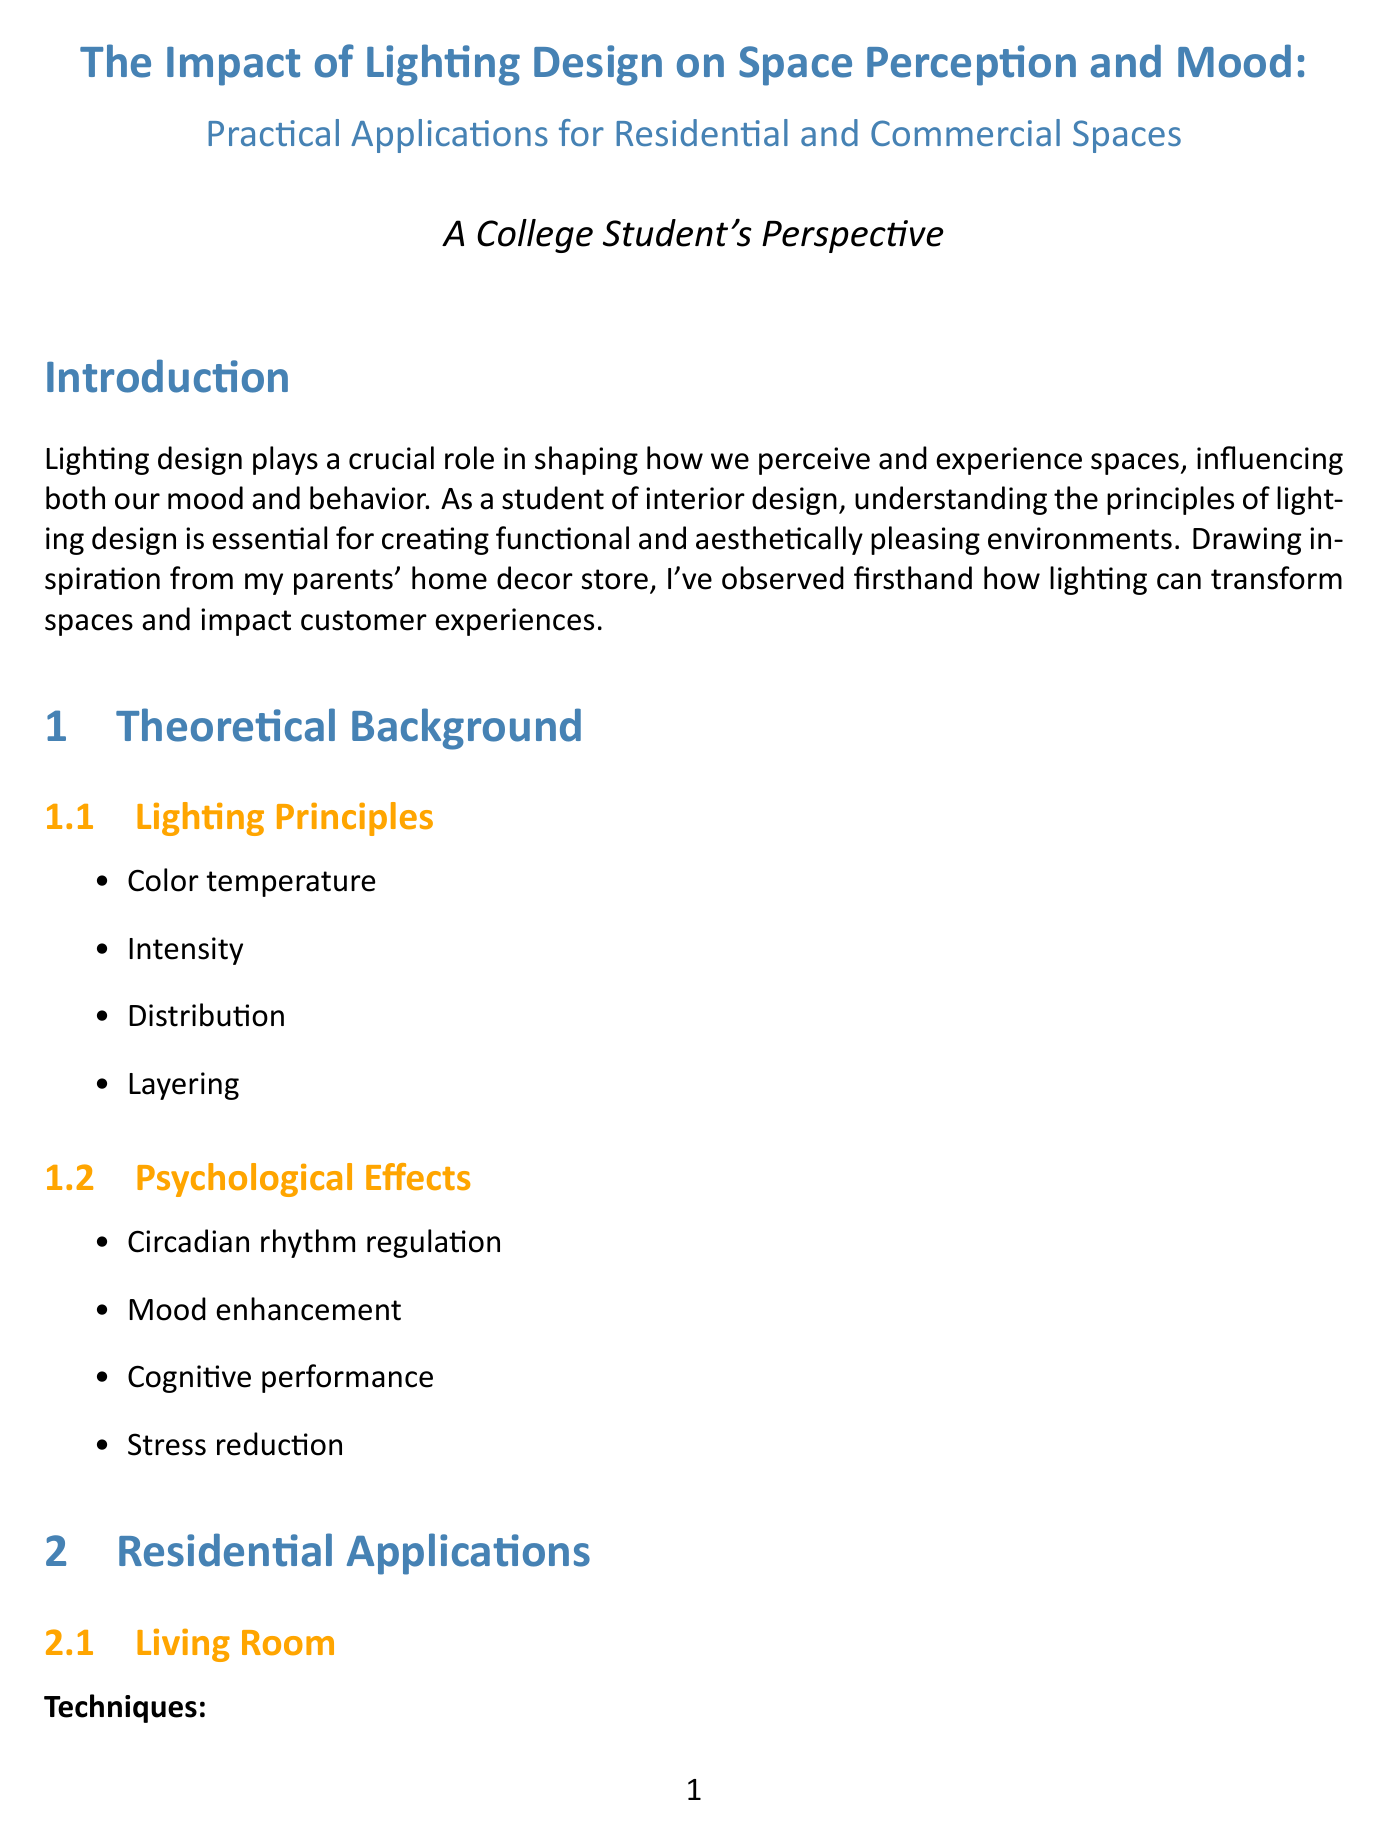what is the report title? The report title is provided in the document's header, outlining the subject matter.
Answer: The Impact of Lighting Design on Space Perception and Mood: Practical Applications for Residential and Commercial Spaces which case study is referenced for bedroom lighting techniques? The case study highlighted for bedroom lighting techniques exemplifies practical application within hospitality spaces.
Answer: Marriott Hotels' StayWell Rooms what is one technique used for kitchen lighting? The document lists specific lighting techniques for various spaces, including kitchens.
Answer: Under-cabinet LED strips for task lighting name a psychological effect of lighting design mentioned in the report. The report discusses various psychological effects that lighting can have on individuals, highlighting its significance.
Answer: Mood enhancement how many principles of lighting are discussed in the theoretical background? The theoretical background section enumerates specific principles related to lighting design, which are vital to understanding the subject.
Answer: Four 